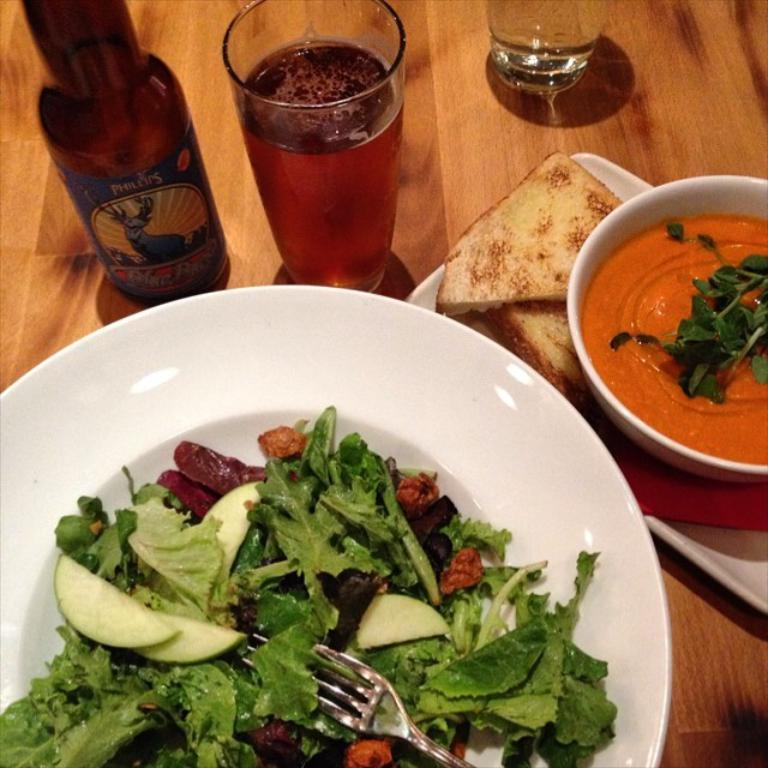What type of table is in the image? There is a wooden table in the image. What is on the table? There is a white plate on the table, which contains salad. What utensil is on the plate? There is a fork on the plate. What else can be seen on the table? There are glasses and a glass bottle on the table. What is in the bowl on the table? There are breads and other food items in the bowl. Can you see any bones on the table in the image? There are no bones visible in the image. What type of rail is present in the image? There is no rail present in the image. 